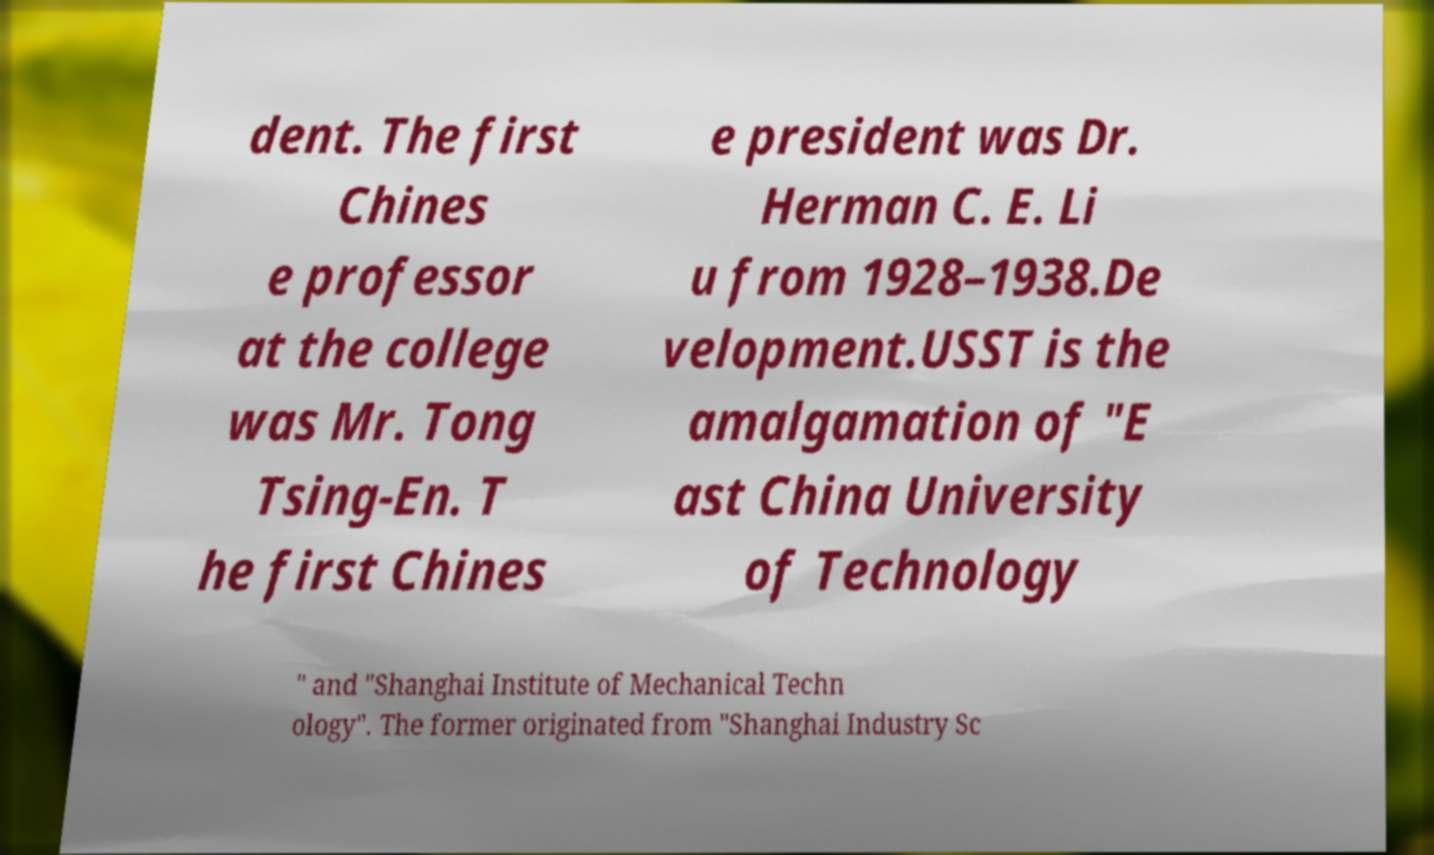I need the written content from this picture converted into text. Can you do that? dent. The first Chines e professor at the college was Mr. Tong Tsing-En. T he first Chines e president was Dr. Herman C. E. Li u from 1928–1938.De velopment.USST is the amalgamation of "E ast China University of Technology " and "Shanghai Institute of Mechanical Techn ology". The former originated from "Shanghai Industry Sc 